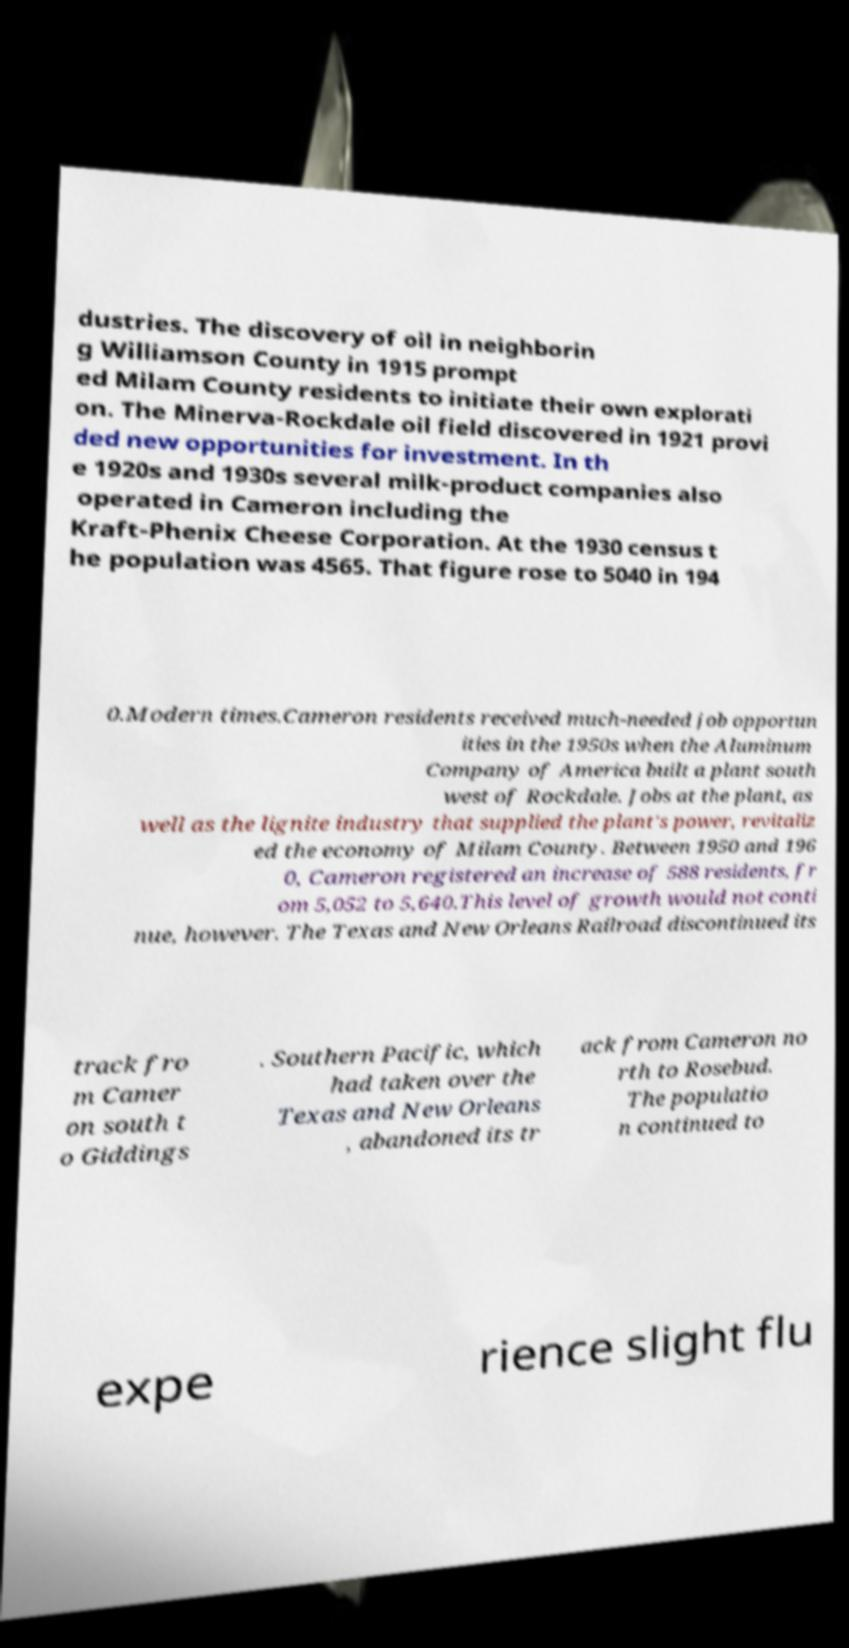There's text embedded in this image that I need extracted. Can you transcribe it verbatim? dustries. The discovery of oil in neighborin g Williamson County in 1915 prompt ed Milam County residents to initiate their own explorati on. The Minerva-Rockdale oil field discovered in 1921 provi ded new opportunities for investment. In th e 1920s and 1930s several milk-product companies also operated in Cameron including the Kraft-Phenix Cheese Corporation. At the 1930 census t he population was 4565. That figure rose to 5040 in 194 0.Modern times.Cameron residents received much-needed job opportun ities in the 1950s when the Aluminum Company of America built a plant south west of Rockdale. Jobs at the plant, as well as the lignite industry that supplied the plant's power, revitaliz ed the economy of Milam County. Between 1950 and 196 0, Cameron registered an increase of 588 residents, fr om 5,052 to 5,640.This level of growth would not conti nue, however. The Texas and New Orleans Railroad discontinued its track fro m Camer on south t o Giddings . Southern Pacific, which had taken over the Texas and New Orleans , abandoned its tr ack from Cameron no rth to Rosebud. The populatio n continued to expe rience slight flu 